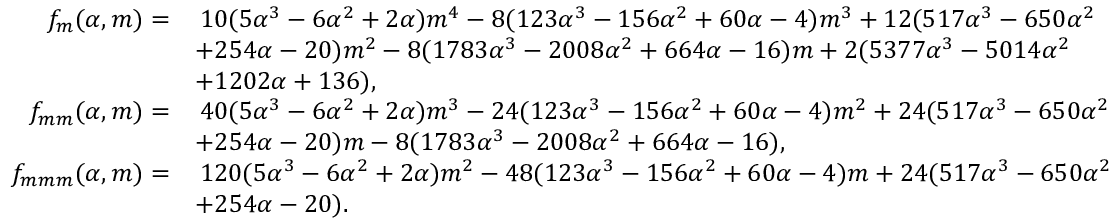<formula> <loc_0><loc_0><loc_500><loc_500>\begin{array} { r l } { f _ { m } ( \alpha , m ) = } & { \, 1 0 ( 5 \alpha ^ { 3 } - 6 \alpha ^ { 2 } + 2 \alpha ) m ^ { 4 } - 8 ( 1 2 3 \alpha ^ { 3 } - 1 5 6 \alpha ^ { 2 } + 6 0 \alpha - 4 ) m ^ { 3 } + 1 2 ( 5 1 7 \alpha ^ { 3 } - 6 5 0 \alpha ^ { 2 } } \\ & { + 2 5 4 \alpha - 2 0 ) m ^ { 2 } - 8 ( 1 7 8 3 \alpha ^ { 3 } - 2 0 0 8 \alpha ^ { 2 } + 6 6 4 \alpha - 1 6 ) m + 2 ( 5 3 7 7 \alpha ^ { 3 } - 5 0 1 4 \alpha ^ { 2 } } \\ & { + 1 2 0 2 \alpha + 1 3 6 ) , } \\ { f _ { m m } ( \alpha , m ) = } & { \, 4 0 ( 5 \alpha ^ { 3 } - 6 \alpha ^ { 2 } + 2 \alpha ) m ^ { 3 } - 2 4 ( 1 2 3 \alpha ^ { 3 } - 1 5 6 \alpha ^ { 2 } + 6 0 \alpha - 4 ) m ^ { 2 } + 2 4 ( 5 1 7 \alpha ^ { 3 } - 6 5 0 \alpha ^ { 2 } } \\ & { + 2 5 4 \alpha - 2 0 ) m - 8 ( 1 7 8 3 \alpha ^ { 3 } - 2 0 0 8 \alpha ^ { 2 } + 6 6 4 \alpha - 1 6 ) , } \\ { f _ { m m m } ( \alpha , m ) = } & { \, 1 2 0 ( 5 \alpha ^ { 3 } - 6 \alpha ^ { 2 } + 2 \alpha ) m ^ { 2 } - 4 8 ( 1 2 3 \alpha ^ { 3 } - 1 5 6 \alpha ^ { 2 } + 6 0 \alpha - 4 ) m + 2 4 ( 5 1 7 \alpha ^ { 3 } - 6 5 0 \alpha ^ { 2 } } \\ & { + 2 5 4 \alpha - 2 0 ) . } \end{array}</formula> 